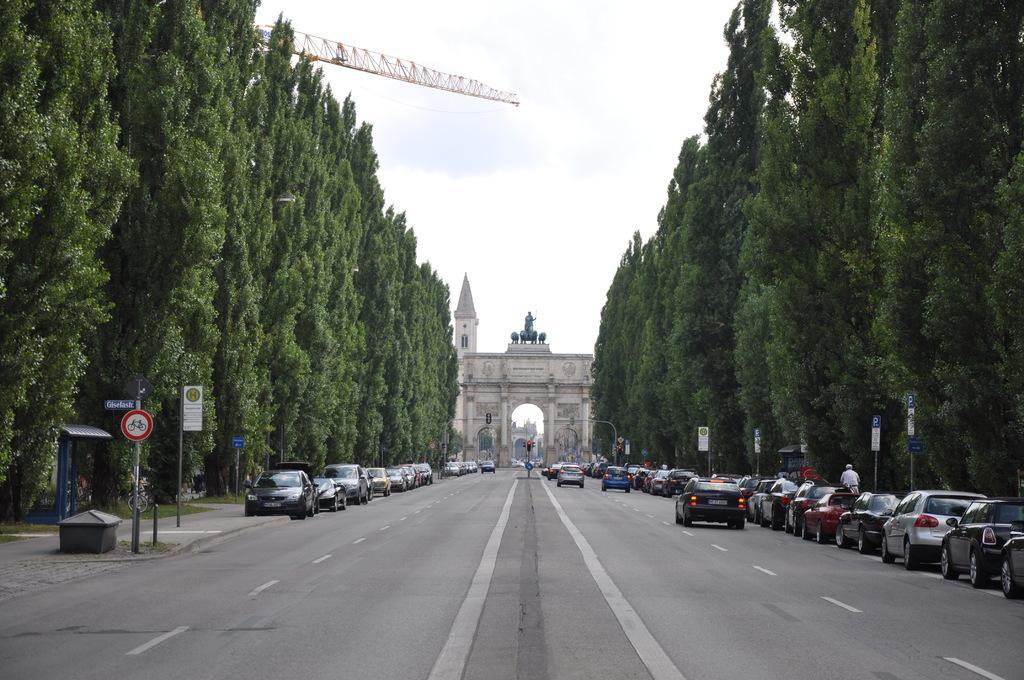How would you summarize this image in a sentence or two? On the left side of the image and right side of the image there are trees, vehicles, boards, poles, crane tower and objects. In the middle of the image there are arches, road, vehicles, statues, tower and objects. In the background of the image I can see the cloudy sky. Near that vehicle I can see a person. 